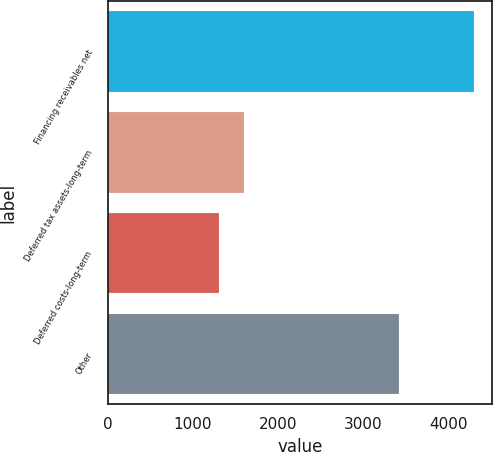Convert chart to OTSL. <chart><loc_0><loc_0><loc_500><loc_500><bar_chart><fcel>Financing receivables net<fcel>Deferred tax assets-long-term<fcel>Deferred costs-long-term<fcel>Other<nl><fcel>4292<fcel>1600.1<fcel>1301<fcel>3419<nl></chart> 